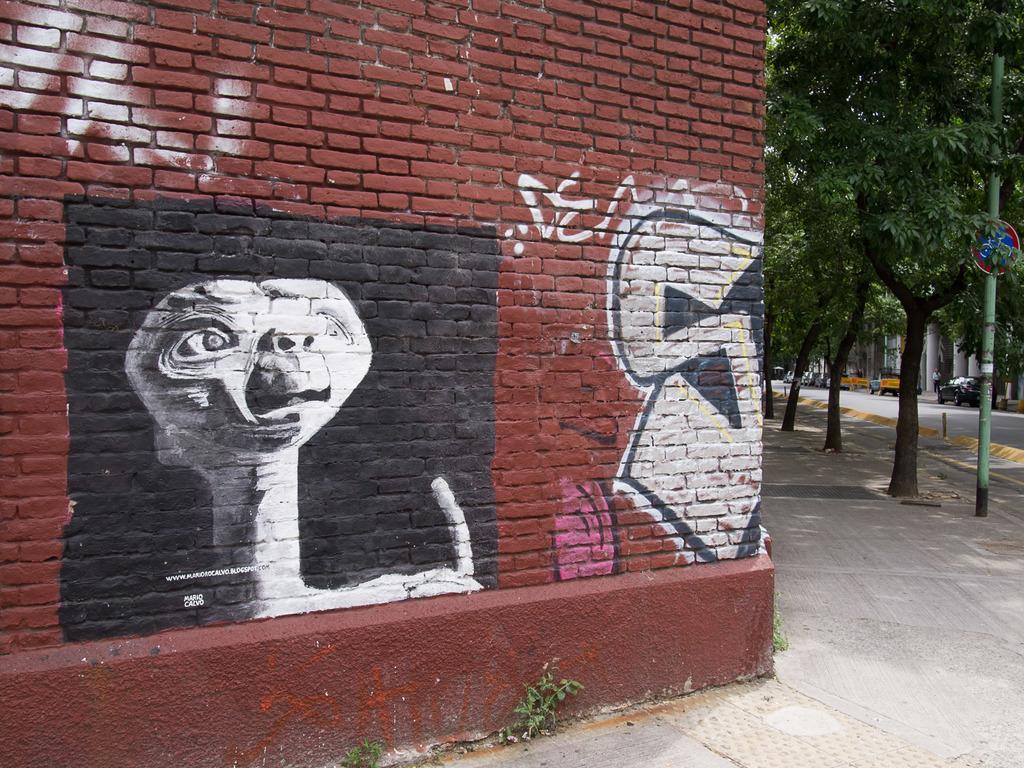Could you give a brief overview of what you see in this image? In this image I can see a red colour wall in the front and on it I can see graffiti. On the right side of this image I can see few trees, a pole, a sign board, a road and on it I can see number of vehicles. 